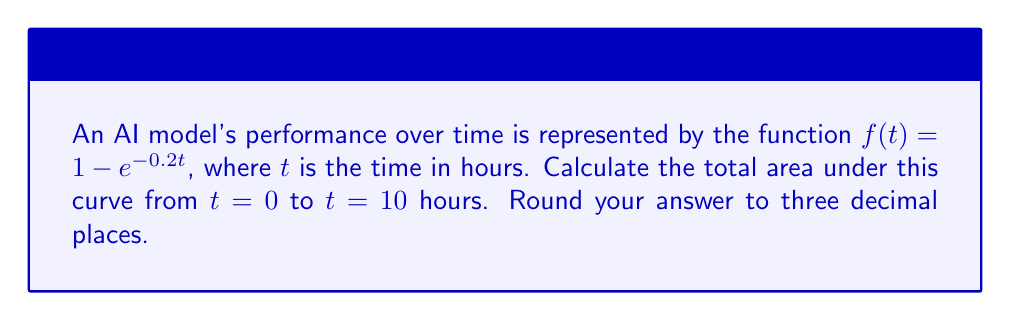Could you help me with this problem? To find the area under the curve, we need to integrate the function $f(t) = 1 - e^{-0.2t}$ from $t = 0$ to $t = 10$. Let's follow these steps:

1) Set up the definite integral:
   $$\int_0^{10} (1 - e^{-0.2t}) dt$$

2) Separate the integral:
   $$\int_0^{10} 1 dt - \int_0^{10} e^{-0.2t} dt$$

3) Integrate the first part:
   $$[t]_0^{10} - \int_0^{10} e^{-0.2t} dt$$

4) For the second part, use the rule $\int e^{ax} dx = \frac{1}{a}e^{ax} + C$:
   $$[t]_0^{10} - [-5e^{-0.2t}]_0^{10}$$

5) Evaluate the definite integral:
   $$(10 - 0) - (-5e^{-2} - (-5))$$

6) Simplify:
   $$10 - (-5e^{-2} + 5)$$
   $$10 + 5e^{-2} - 5$$
   $$5 + 5e^{-2}$$

7) Calculate and round to three decimal places:
   $$5 + 5(0.1353) = 5.677$$
Answer: 5.677 